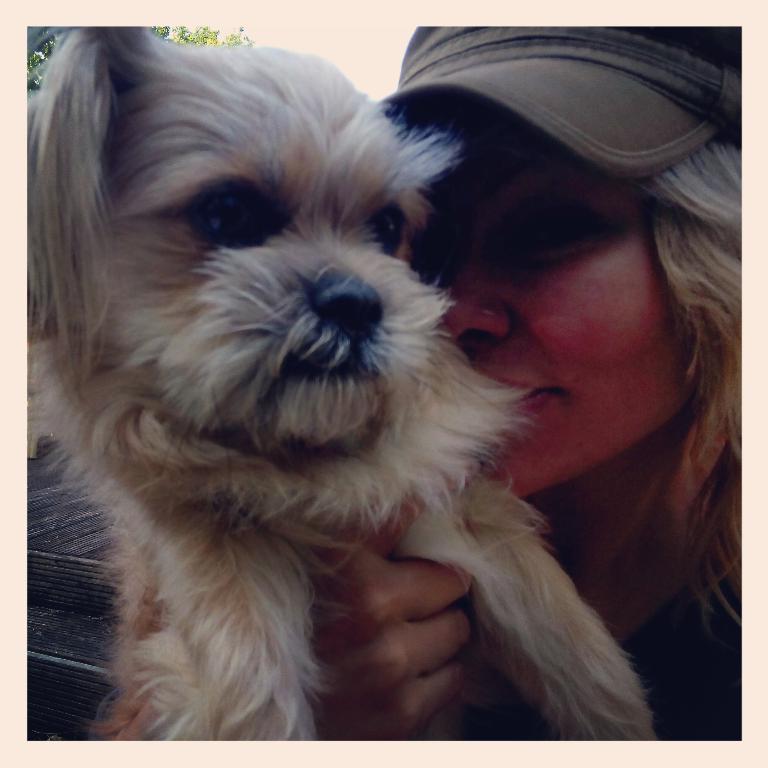Can you describe this image briefly? This image consists of a woman holding a dog. She is wearing a cap. In the background, there is a tree. 